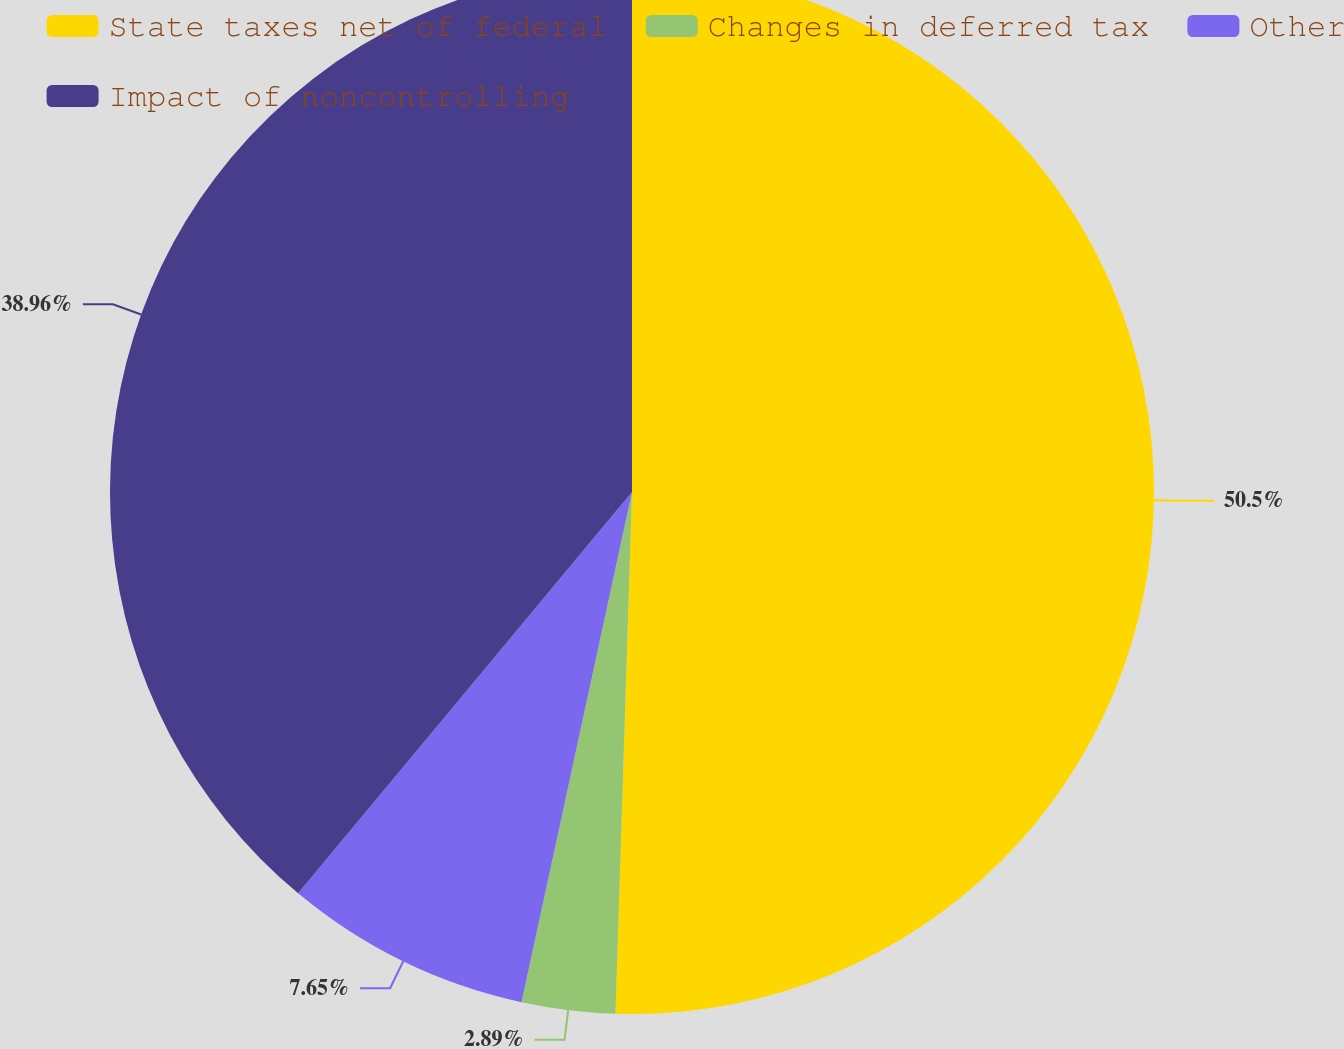<chart> <loc_0><loc_0><loc_500><loc_500><pie_chart><fcel>State taxes net of federal<fcel>Changes in deferred tax<fcel>Other<fcel>Impact of noncontrolling<nl><fcel>50.51%<fcel>2.89%<fcel>7.65%<fcel>38.96%<nl></chart> 